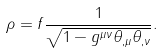<formula> <loc_0><loc_0><loc_500><loc_500>\rho = f \frac { 1 } { \sqrt { 1 - g ^ { \mu \nu } \theta _ { , \mu } \theta _ { , \nu } } } .</formula> 